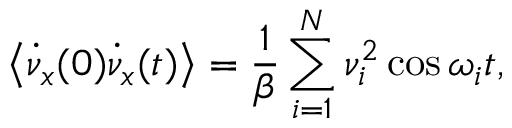<formula> <loc_0><loc_0><loc_500><loc_500>\left < \dot { \nu } _ { x } ( 0 ) \dot { \nu } _ { x } ( t ) \right > = { \frac { 1 } { \beta } } \sum _ { i = 1 } ^ { N } \nu _ { i } ^ { 2 } \cos \omega _ { i } t ,</formula> 